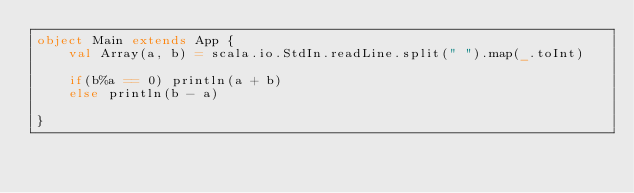Convert code to text. <code><loc_0><loc_0><loc_500><loc_500><_Scala_>object Main extends App {
	val Array(a, b) = scala.io.StdIn.readLine.split(" ").map(_.toInt)
 
	if(b%a == 0) println(a + b)
	else println(b - a)
 
}</code> 